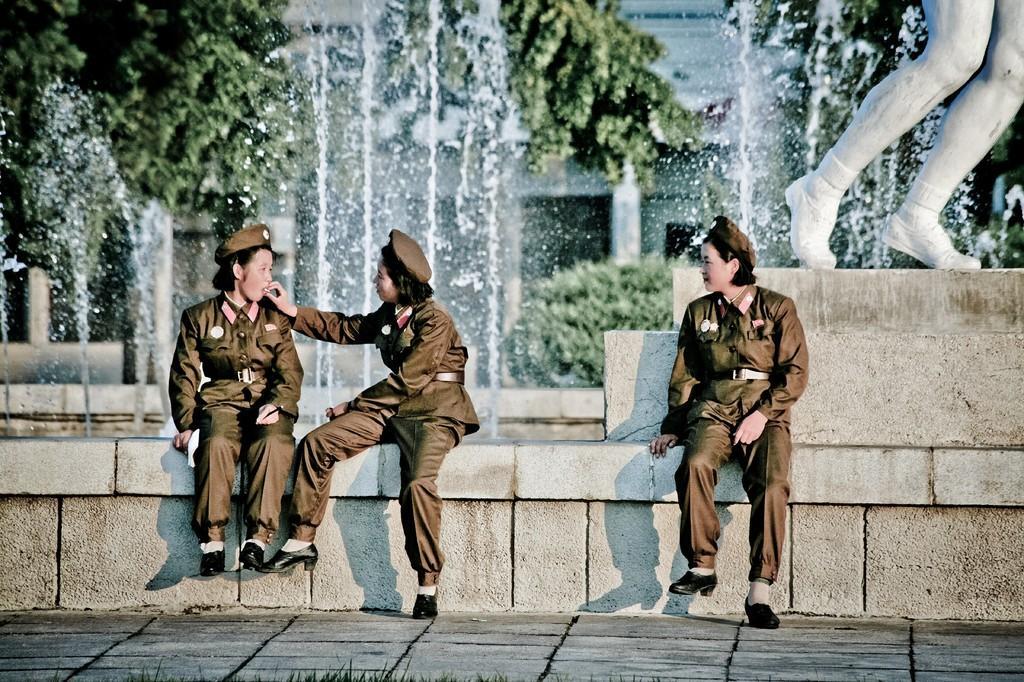Could you give a brief overview of what you see in this image? In this image we can see three women sitting on the wall of a fountain and a woman is holding an object, there is a sculpture behind a woman and there are few trees and a building in the background. 